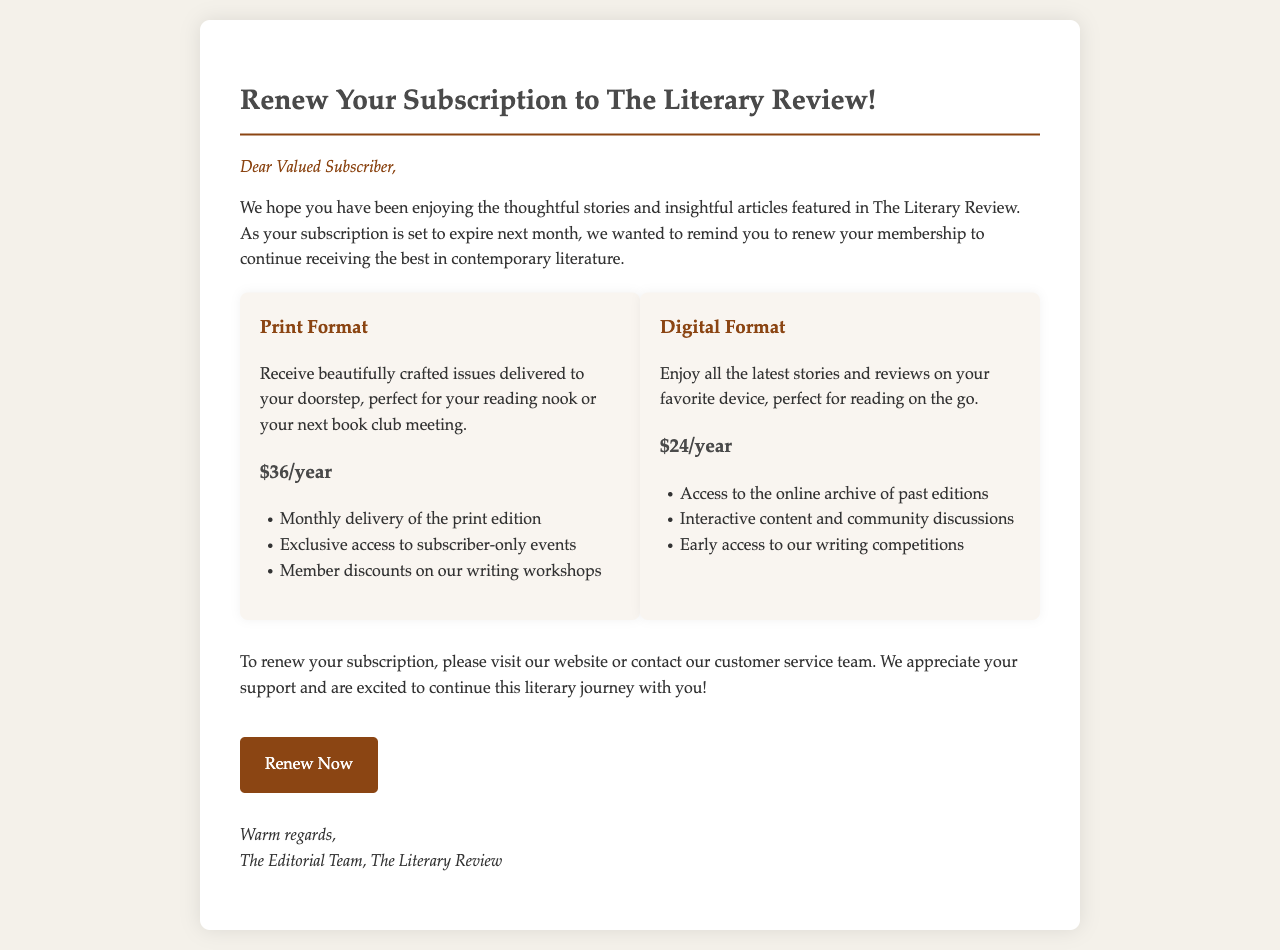What is the price for the Print Format subscription? The price for the Print Format subscription is specifically stated in the document.
Answer: $36/year What are the benefits of the Digital Format subscription? The benefits are listed in a bullet format below the Digital Format option.
Answer: Access to the online archive of past editions, Interactive content and community discussions, Early access to our writing competitions What is the main purpose of this email? The email serves to remind subscribers that their subscription is about to expire and prompts them to renew.
Answer: Renew subscription What is the greeting in the email? The greeting is found at the beginning of the email, addressing the recipient directly.
Answer: Dear Valued Subscriber How often will Print Format editions be delivered? This information can be inferred from the description provided for the Print Format subscription.
Answer: Monthly What year does the renewal cover for the Digital Format? The duration of the Digital Format subscription is explicitly mentioned.
Answer: $24/year What is the call-to-action phrase in the email? The call-to-action phrase is a specific instruction to the reader that encourages them to take action.
Answer: Renew Now What should subscribers do to renew their subscription? The document provides a general instruction for renewal.
Answer: Visit our website or contact customer service What is included in the benefits for Print Format subscribers? The benefits are listed under the Print Format section in a bullet format.
Answer: Monthly delivery of the print edition, Exclusive access to subscriber-only events, Member discounts on our writing workshops 